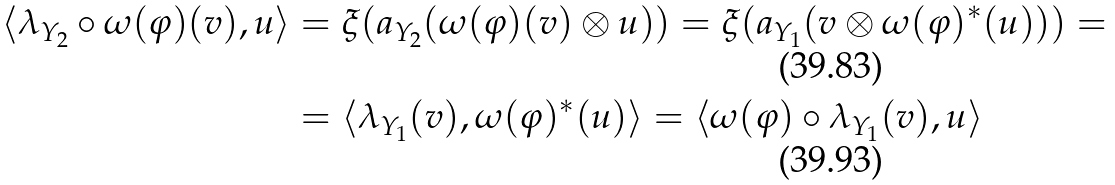<formula> <loc_0><loc_0><loc_500><loc_500>\langle \lambda _ { Y _ { 2 } } \circ \omega ( \varphi ) ( v ) , u \rangle & = \xi ( a _ { Y _ { 2 } } ( \omega ( \varphi ) ( v ) \otimes u ) ) = \xi ( a _ { Y _ { 1 } } ( v \otimes \omega ( \varphi ) ^ { * } ( u ) ) ) = \\ & = \langle \lambda _ { Y _ { 1 } } ( v ) , \omega ( \varphi ) ^ { * } ( u ) \rangle = \langle \omega ( \varphi ) \circ \lambda _ { Y _ { 1 } } ( v ) , u \rangle</formula> 